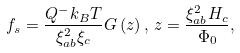Convert formula to latex. <formula><loc_0><loc_0><loc_500><loc_500>f _ { s } = \frac { Q ^ { - } k _ { B } T } { \xi _ { a b } ^ { 2 } \xi _ { c } } G \left ( z \right ) , \, z = \frac { \xi _ { a b } ^ { 2 } H _ { c } } { \Phi _ { 0 } } ,</formula> 